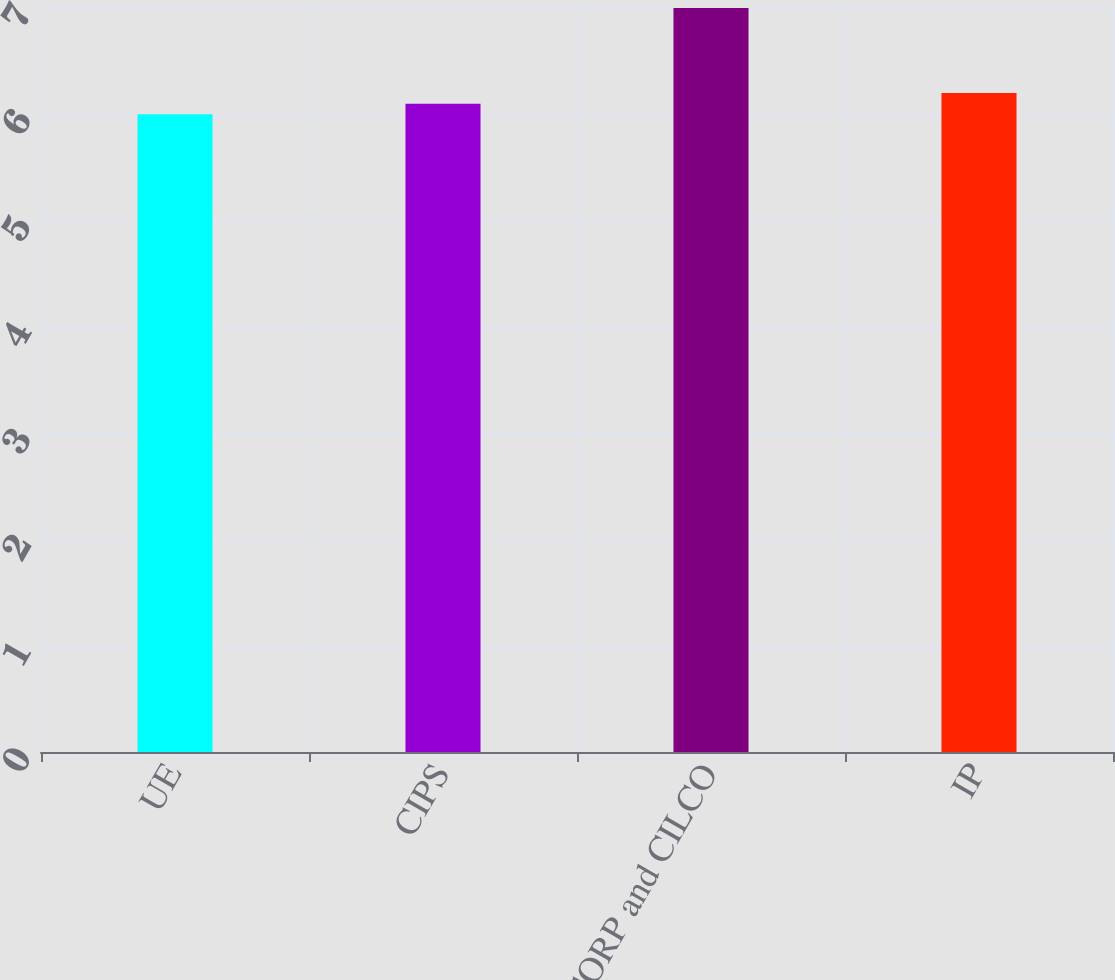<chart> <loc_0><loc_0><loc_500><loc_500><bar_chart><fcel>UE<fcel>CIPS<fcel>CILCORP and CILCO<fcel>IP<nl><fcel>6<fcel>6.1<fcel>7<fcel>6.2<nl></chart> 